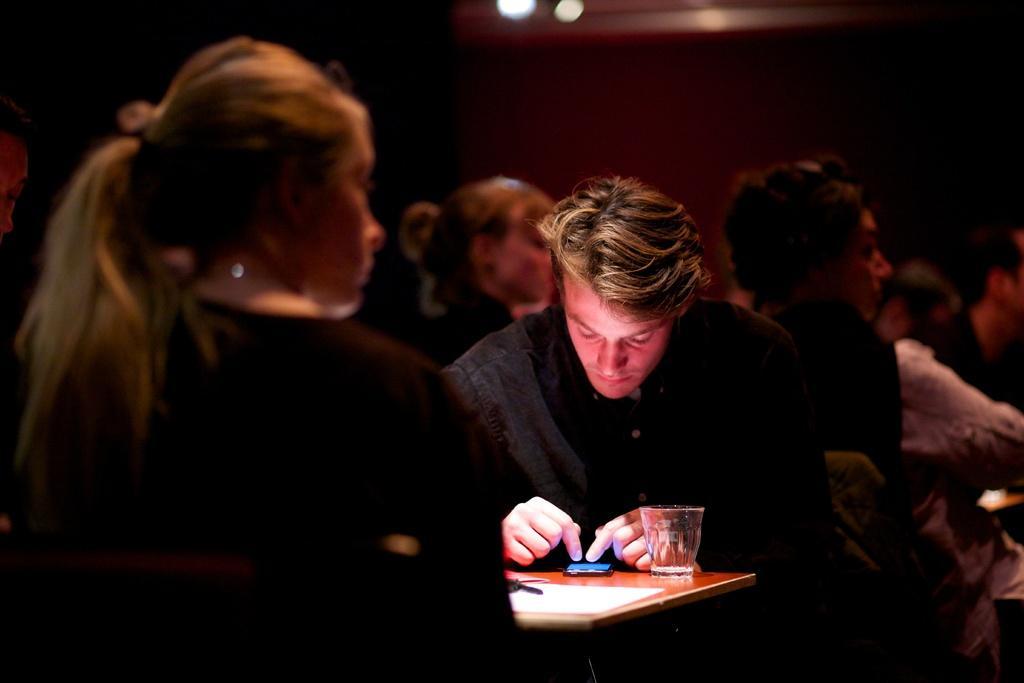In one or two sentences, can you explain what this image depicts? In this image I can see a person sitting. In front I can see mobile,glass,paper and some objects on the table. Back I can see few people around. Background is in dark in color. 